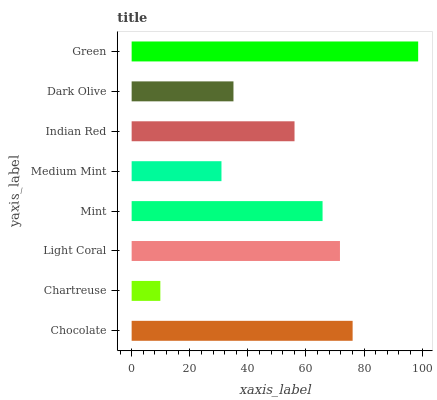Is Chartreuse the minimum?
Answer yes or no. Yes. Is Green the maximum?
Answer yes or no. Yes. Is Light Coral the minimum?
Answer yes or no. No. Is Light Coral the maximum?
Answer yes or no. No. Is Light Coral greater than Chartreuse?
Answer yes or no. Yes. Is Chartreuse less than Light Coral?
Answer yes or no. Yes. Is Chartreuse greater than Light Coral?
Answer yes or no. No. Is Light Coral less than Chartreuse?
Answer yes or no. No. Is Mint the high median?
Answer yes or no. Yes. Is Indian Red the low median?
Answer yes or no. Yes. Is Green the high median?
Answer yes or no. No. Is Chartreuse the low median?
Answer yes or no. No. 